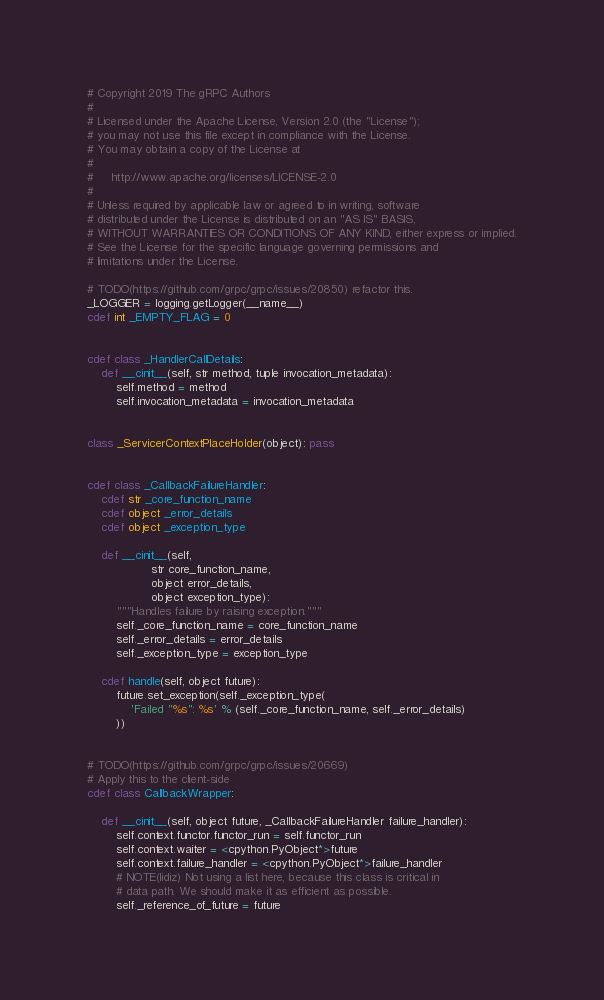<code> <loc_0><loc_0><loc_500><loc_500><_Cython_># Copyright 2019 The gRPC Authors
#
# Licensed under the Apache License, Version 2.0 (the "License");
# you may not use this file except in compliance with the License.
# You may obtain a copy of the License at
#
#     http://www.apache.org/licenses/LICENSE-2.0
#
# Unless required by applicable law or agreed to in writing, software
# distributed under the License is distributed on an "AS IS" BASIS,
# WITHOUT WARRANTIES OR CONDITIONS OF ANY KIND, either express or implied.
# See the License for the specific language governing permissions and
# limitations under the License.

# TODO(https://github.com/grpc/grpc/issues/20850) refactor this.
_LOGGER = logging.getLogger(__name__)
cdef int _EMPTY_FLAG = 0


cdef class _HandlerCallDetails:
    def __cinit__(self, str method, tuple invocation_metadata):
        self.method = method
        self.invocation_metadata = invocation_metadata


class _ServicerContextPlaceHolder(object): pass


cdef class _CallbackFailureHandler:
    cdef str _core_function_name
    cdef object _error_details
    cdef object _exception_type

    def __cinit__(self,
                  str core_function_name,
                  object error_details,
                  object exception_type):
        """Handles failure by raising exception."""
        self._core_function_name = core_function_name
        self._error_details = error_details
        self._exception_type = exception_type

    cdef handle(self, object future):
        future.set_exception(self._exception_type(
            'Failed "%s": %s' % (self._core_function_name, self._error_details)
        ))


# TODO(https://github.com/grpc/grpc/issues/20669)
# Apply this to the client-side
cdef class CallbackWrapper:

    def __cinit__(self, object future, _CallbackFailureHandler failure_handler):
        self.context.functor.functor_run = self.functor_run
        self.context.waiter = <cpython.PyObject*>future
        self.context.failure_handler = <cpython.PyObject*>failure_handler
        # NOTE(lidiz) Not using a list here, because this class is critical in
        # data path. We should make it as efficient as possible.
        self._reference_of_future = future</code> 